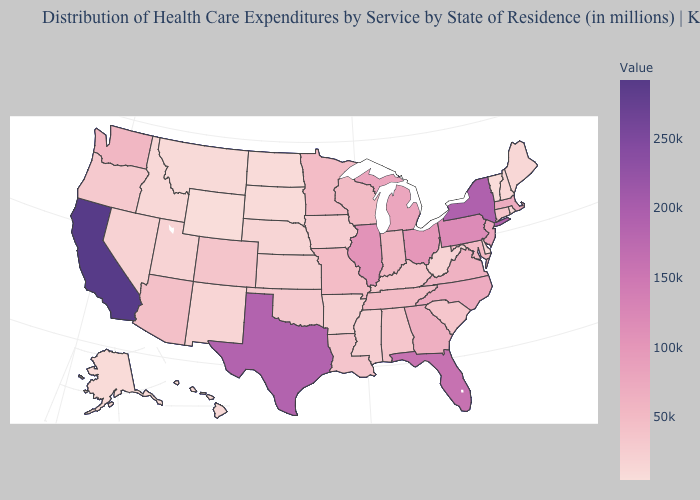Which states have the lowest value in the West?
Keep it brief. Wyoming. Does Wisconsin have a higher value than New Mexico?
Quick response, please. Yes. Among the states that border North Dakota , does South Dakota have the lowest value?
Quick response, please. Yes. Which states have the highest value in the USA?
Be succinct. California. 